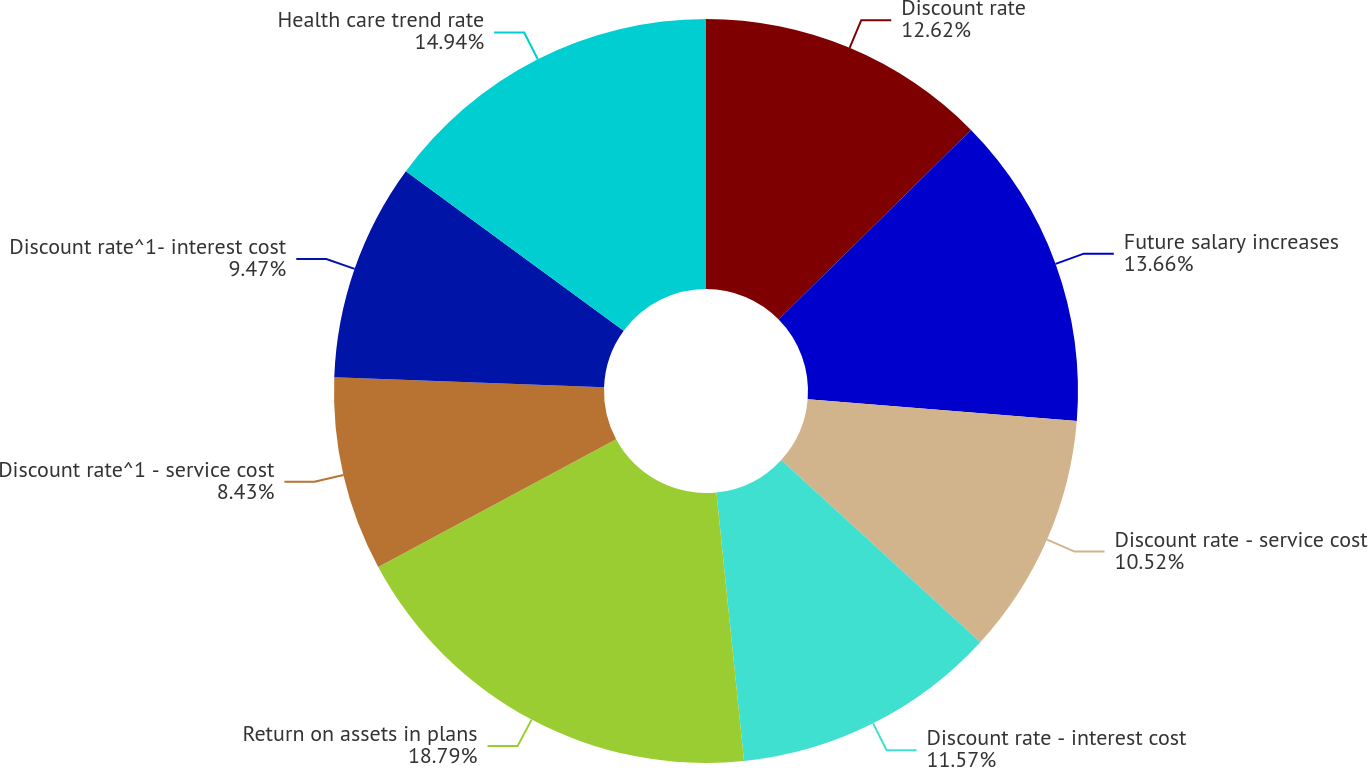<chart> <loc_0><loc_0><loc_500><loc_500><pie_chart><fcel>Discount rate<fcel>Future salary increases<fcel>Discount rate - service cost<fcel>Discount rate - interest cost<fcel>Return on assets in plans<fcel>Discount rate^1 - service cost<fcel>Discount rate^1- interest cost<fcel>Health care trend rate<nl><fcel>12.62%<fcel>13.66%<fcel>10.52%<fcel>11.57%<fcel>18.79%<fcel>8.43%<fcel>9.47%<fcel>14.94%<nl></chart> 